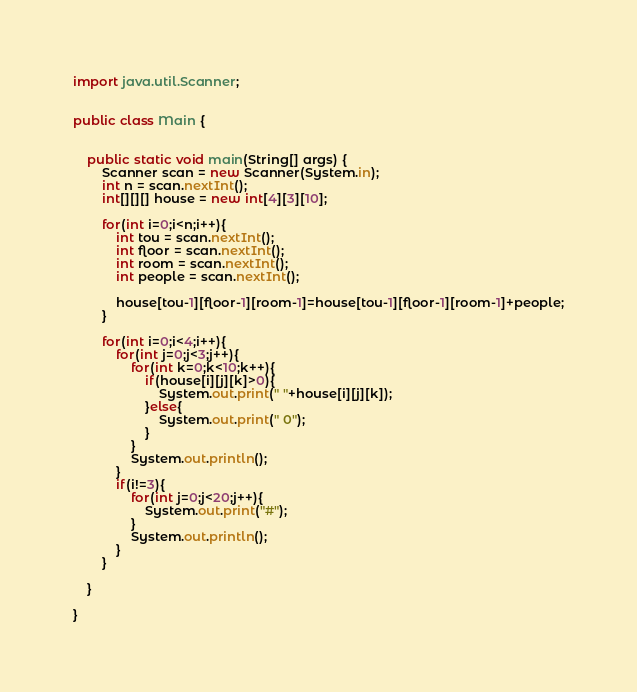Convert code to text. <code><loc_0><loc_0><loc_500><loc_500><_Java_>import java.util.Scanner;


public class Main {


	public static void main(String[] args) {
		Scanner scan = new Scanner(System.in);
		int n = scan.nextInt();
		int[][][] house = new int[4][3][10];

		for(int i=0;i<n;i++){
			int tou = scan.nextInt();
			int floor = scan.nextInt();
			int room = scan.nextInt();
			int people = scan.nextInt();

			house[tou-1][floor-1][room-1]=house[tou-1][floor-1][room-1]+people;
		}

		for(int i=0;i<4;i++){
			for(int j=0;j<3;j++){
				for(int k=0;k<10;k++){
					if(house[i][j][k]>0){
						System.out.print(" "+house[i][j][k]);
					}else{
						System.out.print(" 0");
					}
				}
				System.out.println();
			}
			if(i!=3){
				for(int j=0;j<20;j++){
					System.out.print("#");
				}
				System.out.println();
			}
		}

	}

}</code> 